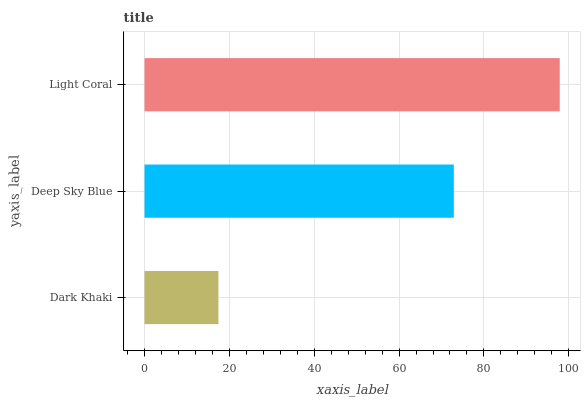Is Dark Khaki the minimum?
Answer yes or no. Yes. Is Light Coral the maximum?
Answer yes or no. Yes. Is Deep Sky Blue the minimum?
Answer yes or no. No. Is Deep Sky Blue the maximum?
Answer yes or no. No. Is Deep Sky Blue greater than Dark Khaki?
Answer yes or no. Yes. Is Dark Khaki less than Deep Sky Blue?
Answer yes or no. Yes. Is Dark Khaki greater than Deep Sky Blue?
Answer yes or no. No. Is Deep Sky Blue less than Dark Khaki?
Answer yes or no. No. Is Deep Sky Blue the high median?
Answer yes or no. Yes. Is Deep Sky Blue the low median?
Answer yes or no. Yes. Is Light Coral the high median?
Answer yes or no. No. Is Light Coral the low median?
Answer yes or no. No. 